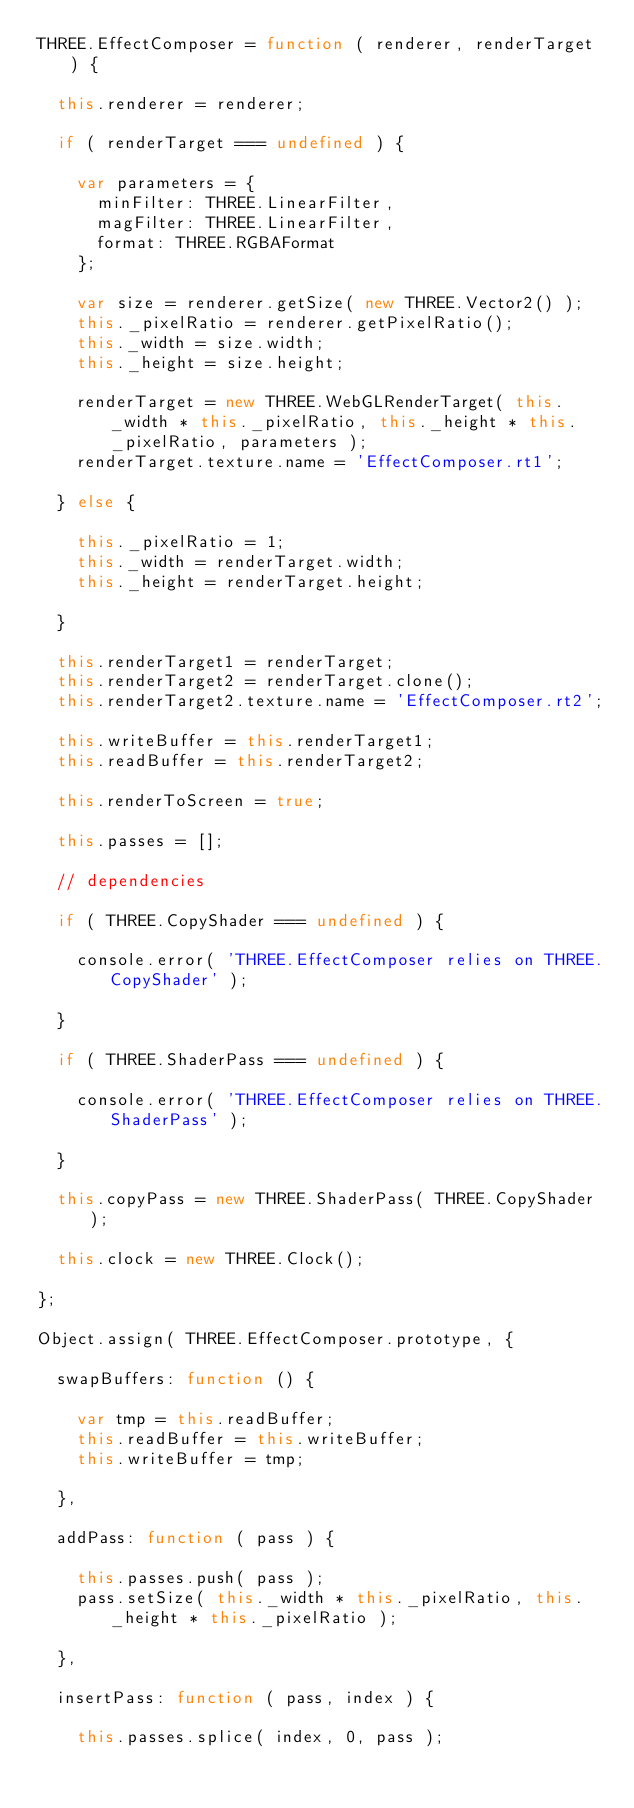Convert code to text. <code><loc_0><loc_0><loc_500><loc_500><_JavaScript_>THREE.EffectComposer = function ( renderer, renderTarget ) {

	this.renderer = renderer;

	if ( renderTarget === undefined ) {

		var parameters = {
			minFilter: THREE.LinearFilter,
			magFilter: THREE.LinearFilter,
			format: THREE.RGBAFormat
		};

		var size = renderer.getSize( new THREE.Vector2() );
		this._pixelRatio = renderer.getPixelRatio();
		this._width = size.width;
		this._height = size.height;

		renderTarget = new THREE.WebGLRenderTarget( this._width * this._pixelRatio, this._height * this._pixelRatio, parameters );
		renderTarget.texture.name = 'EffectComposer.rt1';

	} else {

		this._pixelRatio = 1;
		this._width = renderTarget.width;
		this._height = renderTarget.height;

	}

	this.renderTarget1 = renderTarget;
	this.renderTarget2 = renderTarget.clone();
	this.renderTarget2.texture.name = 'EffectComposer.rt2';

	this.writeBuffer = this.renderTarget1;
	this.readBuffer = this.renderTarget2;

	this.renderToScreen = true;

	this.passes = [];

	// dependencies

	if ( THREE.CopyShader === undefined ) {

		console.error( 'THREE.EffectComposer relies on THREE.CopyShader' );

	}

	if ( THREE.ShaderPass === undefined ) {

		console.error( 'THREE.EffectComposer relies on THREE.ShaderPass' );

	}

	this.copyPass = new THREE.ShaderPass( THREE.CopyShader );

	this.clock = new THREE.Clock();

};

Object.assign( THREE.EffectComposer.prototype, {

	swapBuffers: function () {

		var tmp = this.readBuffer;
		this.readBuffer = this.writeBuffer;
		this.writeBuffer = tmp;

	},

	addPass: function ( pass ) {

		this.passes.push( pass );
		pass.setSize( this._width * this._pixelRatio, this._height * this._pixelRatio );

	},

	insertPass: function ( pass, index ) {

		this.passes.splice( index, 0, pass );</code> 